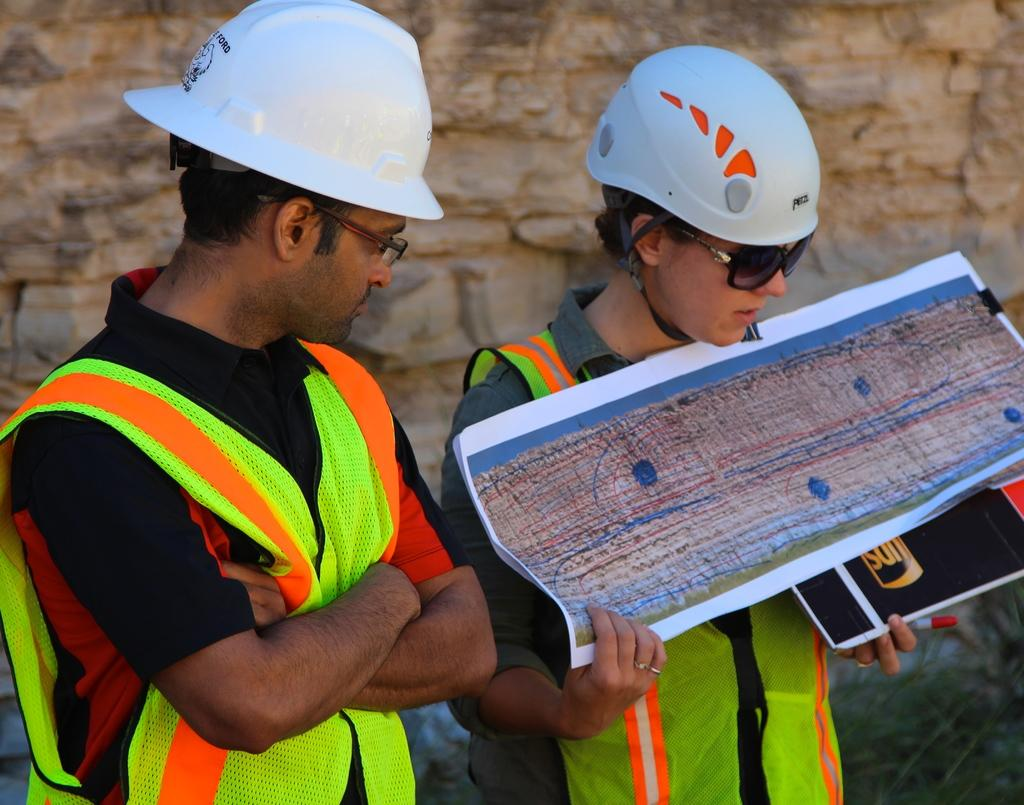Who are the people in the image? There is a man and a woman in the image. What are the man and the woman doing? Both the man and the woman are standing. What protective gear are the man and the woman wearing? The man and the woman are wearing helmets, goggles, and jackets. What is the woman holding in her hands? The woman is holding a book and a paper in her hands. What can be seen in the background of the image? There is a hill visible in the background of the image. What type of jam is the man spreading on the edge of the hill in the image? There is no jam or edge of a hill present in the image. What type of beef is the woman preparing for a barbecue in the image? There is no beef or barbecue present in the image. 